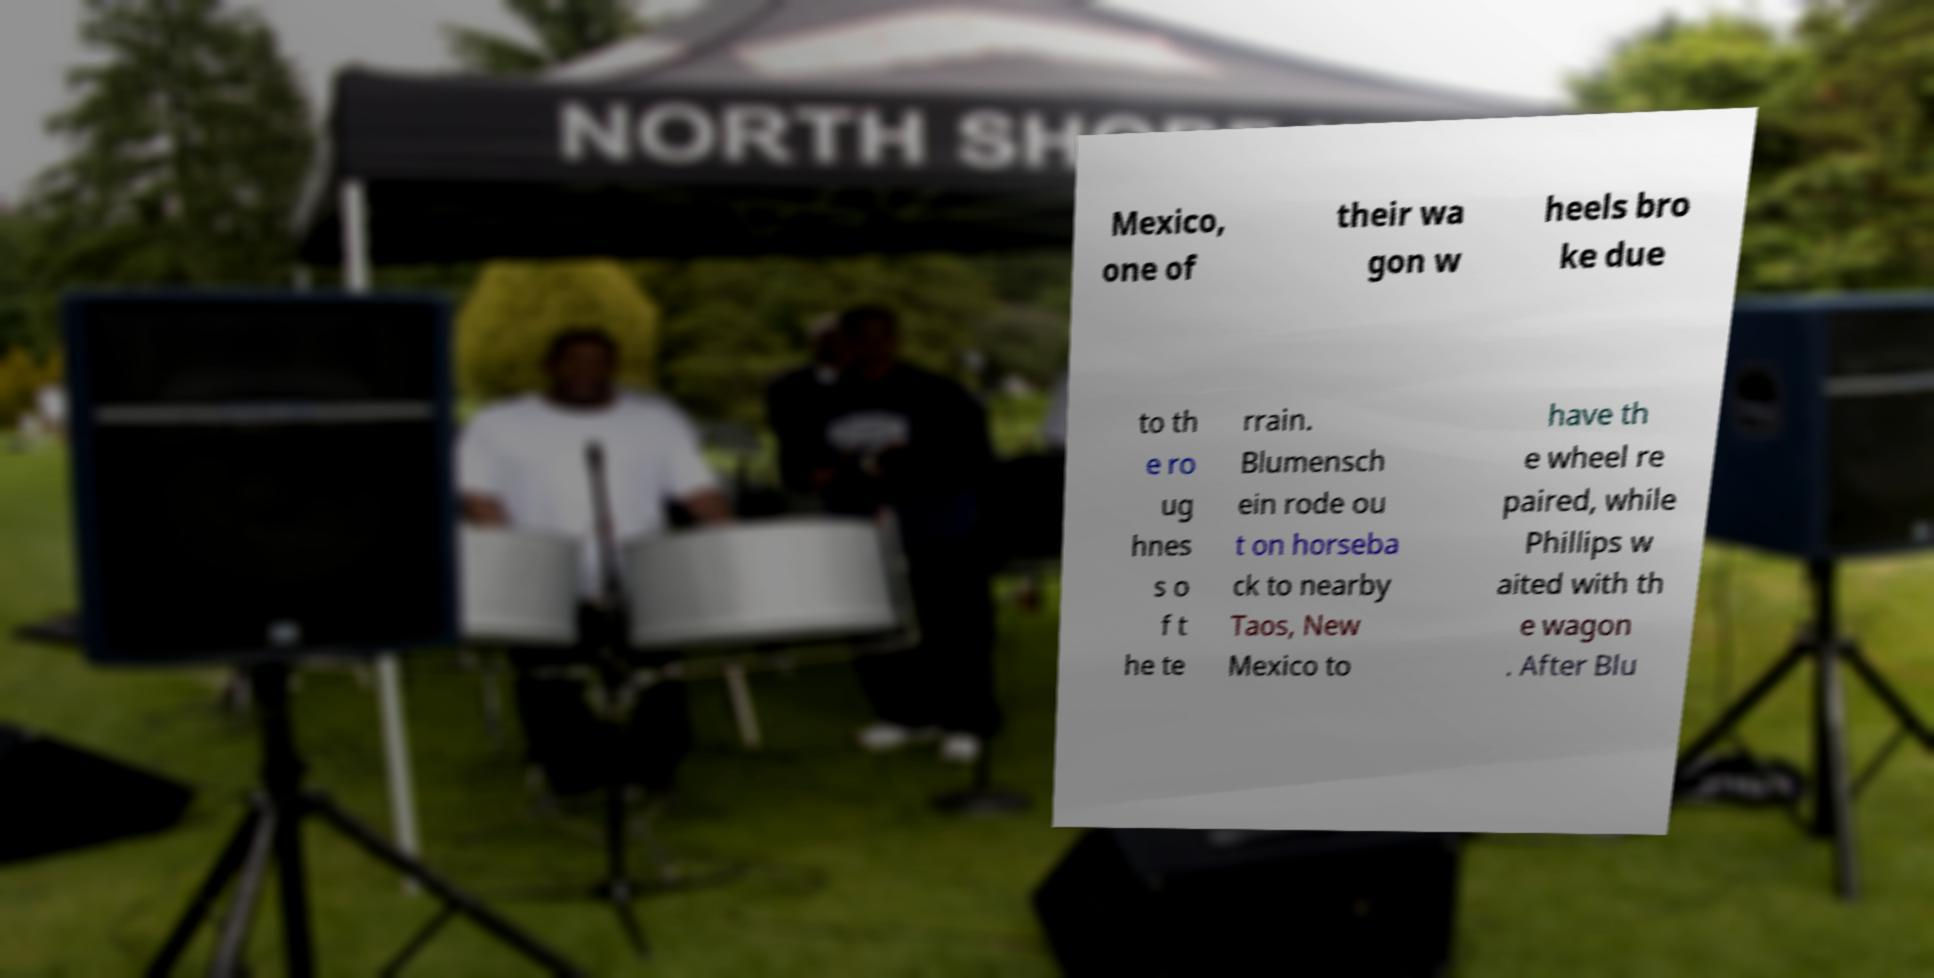Please read and relay the text visible in this image. What does it say? Mexico, one of their wa gon w heels bro ke due to th e ro ug hnes s o f t he te rrain. Blumensch ein rode ou t on horseba ck to nearby Taos, New Mexico to have th e wheel re paired, while Phillips w aited with th e wagon . After Blu 